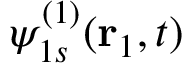<formula> <loc_0><loc_0><loc_500><loc_500>\psi _ { 1 s } ^ { ( 1 ) } ( r _ { 1 } , t )</formula> 